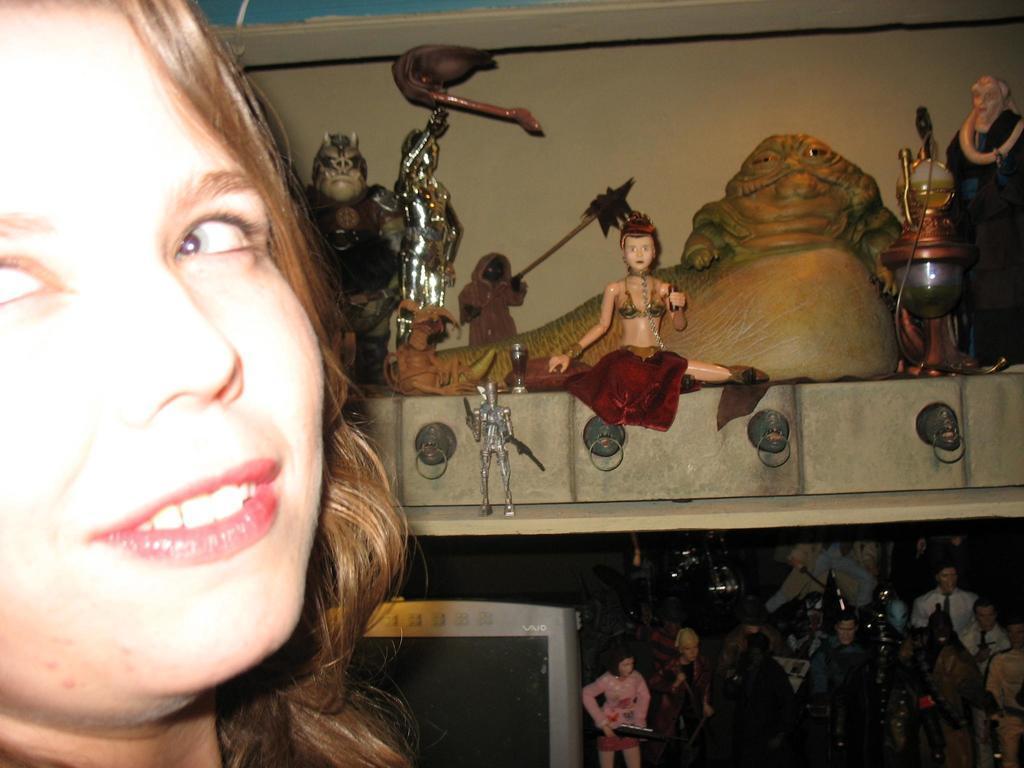Describe this image in one or two sentences. There is a face of a person on the left side of this image and there are some toys and statues are kept in a shelf as we can see on the right side of this image. 